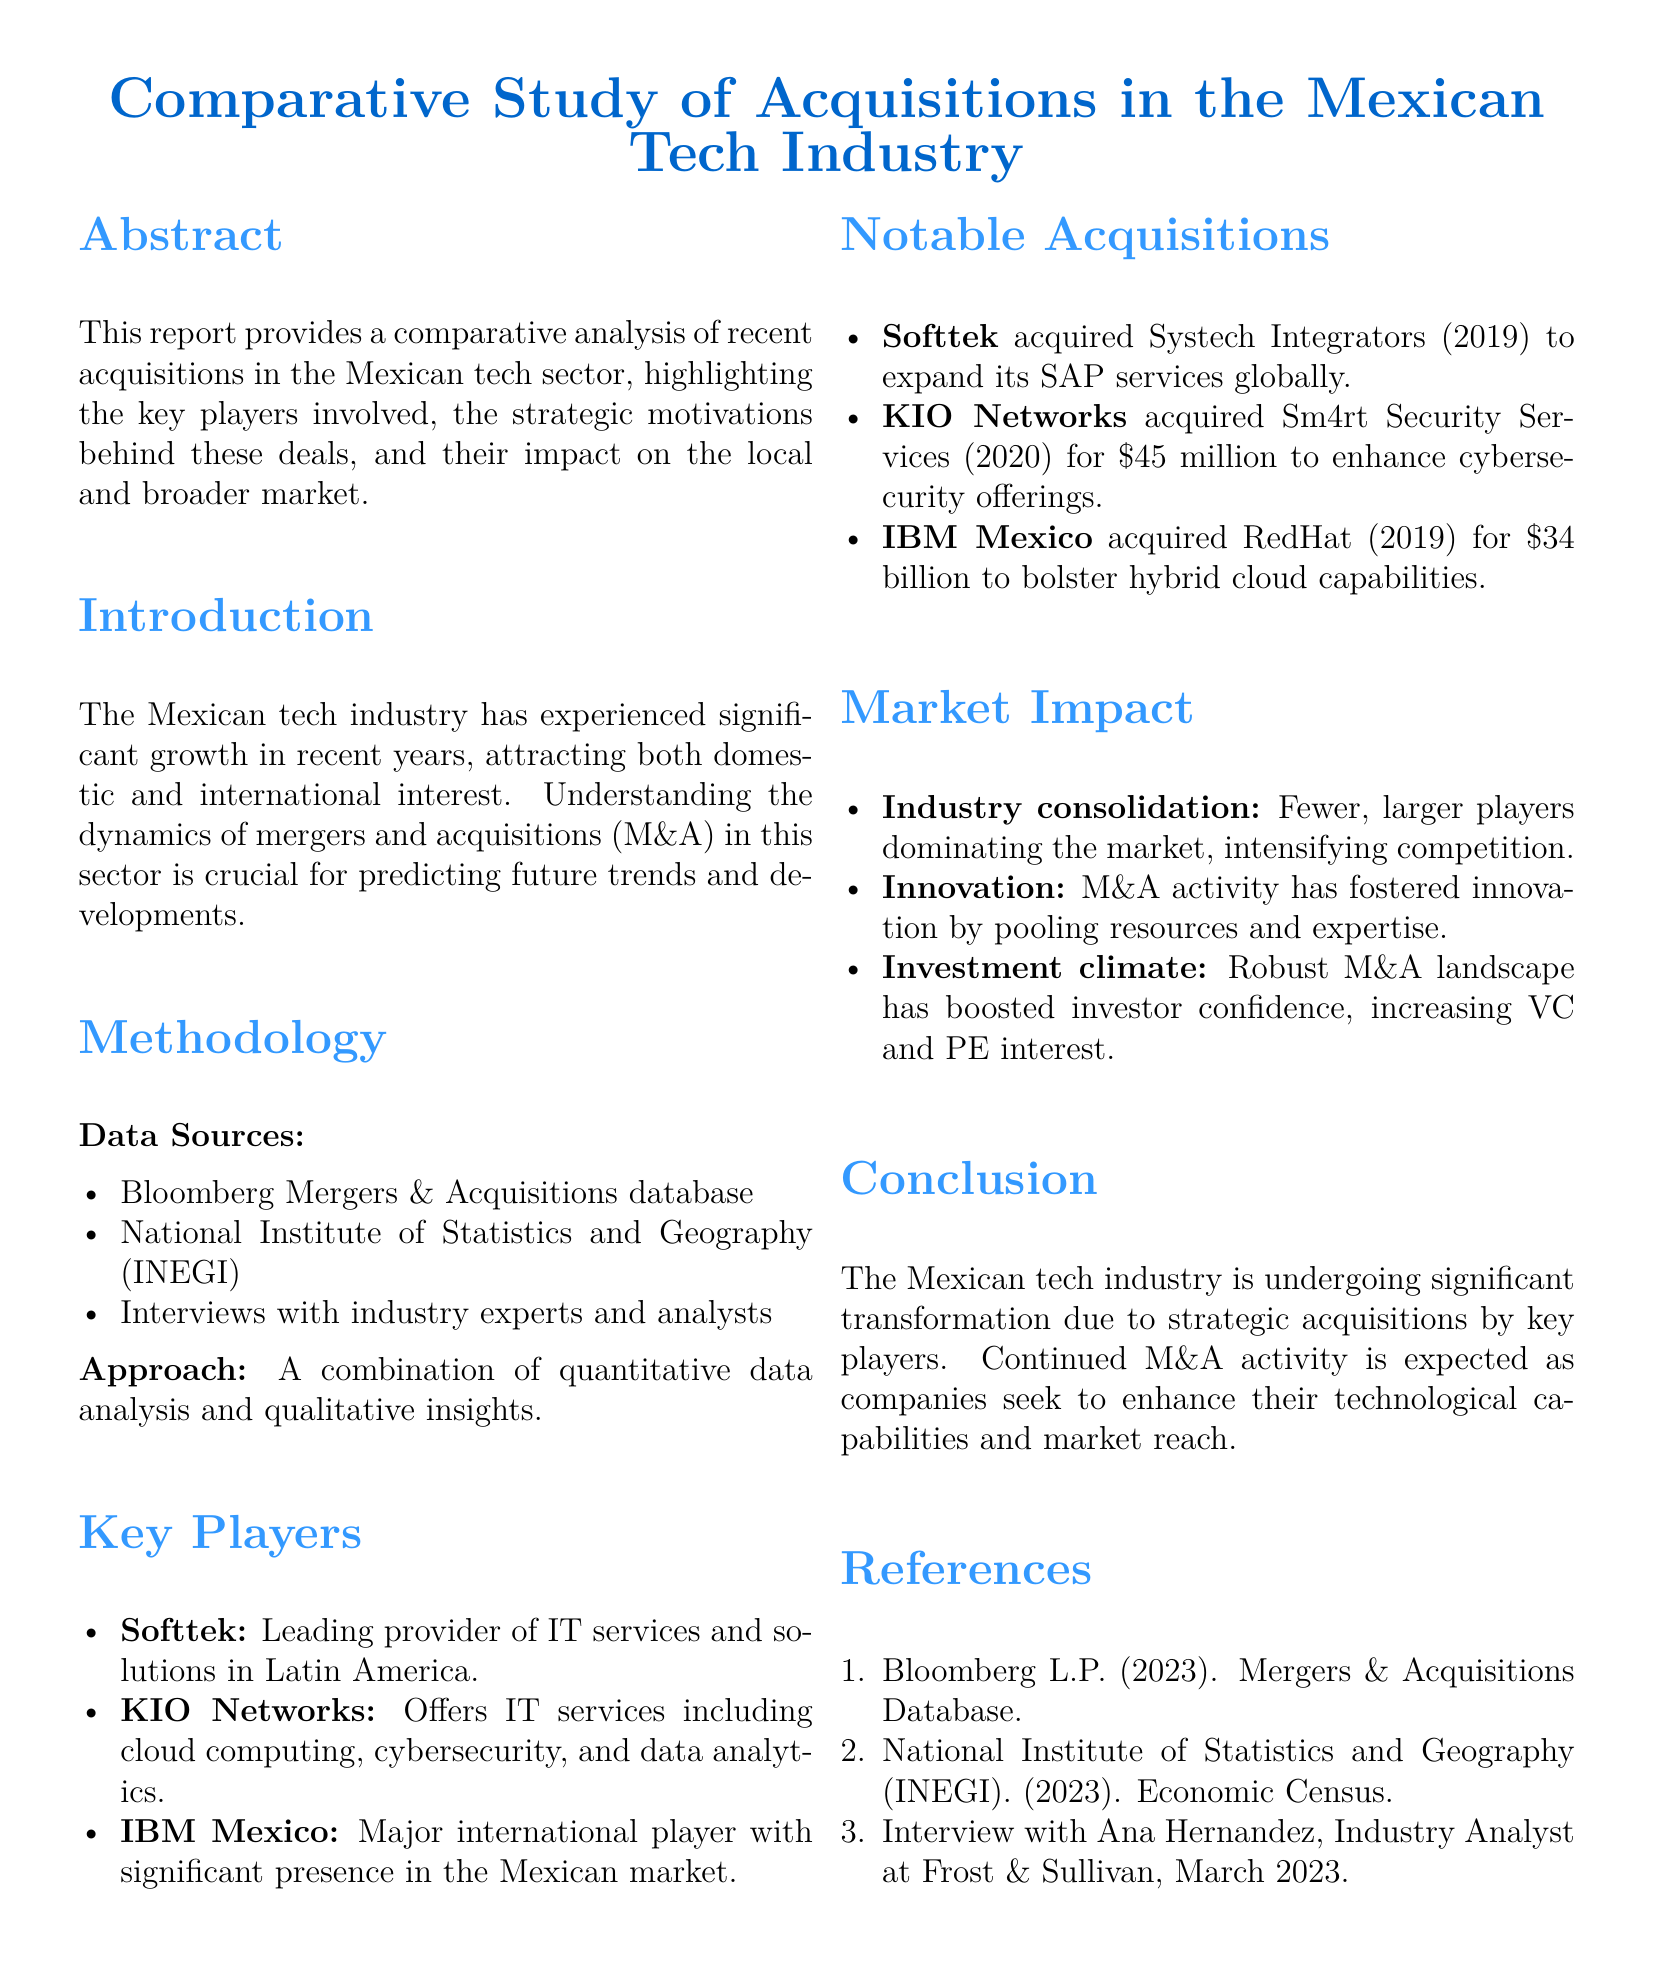What is the focus of the report? The focus of the report is to analyze acquisitions in the Mexican tech sector, highlighting key players, motivations, and market impact.
Answer: Acquisitions in the Mexican tech sector Who acquired Systech Integrators? The document states that Softtek acquired Systech Integrators in 2019 to expand its SAP services globally.
Answer: Softtek What year did KIO Networks acquire Sm4rt Security Services? The acquisition by KIO Networks for Sm4rt Security Services took place in 2020.
Answer: 2020 How much did IBM Mexico pay for RedHat? The document mentions that IBM Mexico acquired RedHat for $34 billion.
Answer: $34 billion What is one of the impacts of M&A activity mentioned? The document highlights that M&A activity has fostered innovation by pooling resources and expertise.
Answer: Innovation Who is a major international player in the Mexican market? IBM Mexico is identified as a major international player within the document.
Answer: IBM Mexico What methodology was used for the analysis? The methodology includes a combination of quantitative data analysis and qualitative insights.
Answer: Quantitative and qualitative analysis According to the document, what has the M&A landscape boosted? The robust M&A landscape has boosted investor confidence, increasing venture capital and private equity interest.
Answer: Investor confidence What year did Softtek's acquisition of Systech occur? The acquisition by Softtek occurred in the year 2019.
Answer: 2019 